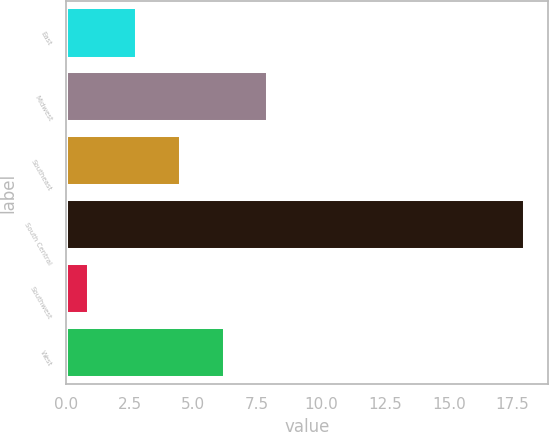Convert chart to OTSL. <chart><loc_0><loc_0><loc_500><loc_500><bar_chart><fcel>East<fcel>Midwest<fcel>Southeast<fcel>South Central<fcel>Southwest<fcel>West<nl><fcel>2.8<fcel>7.93<fcel>4.51<fcel>18<fcel>0.9<fcel>6.22<nl></chart> 